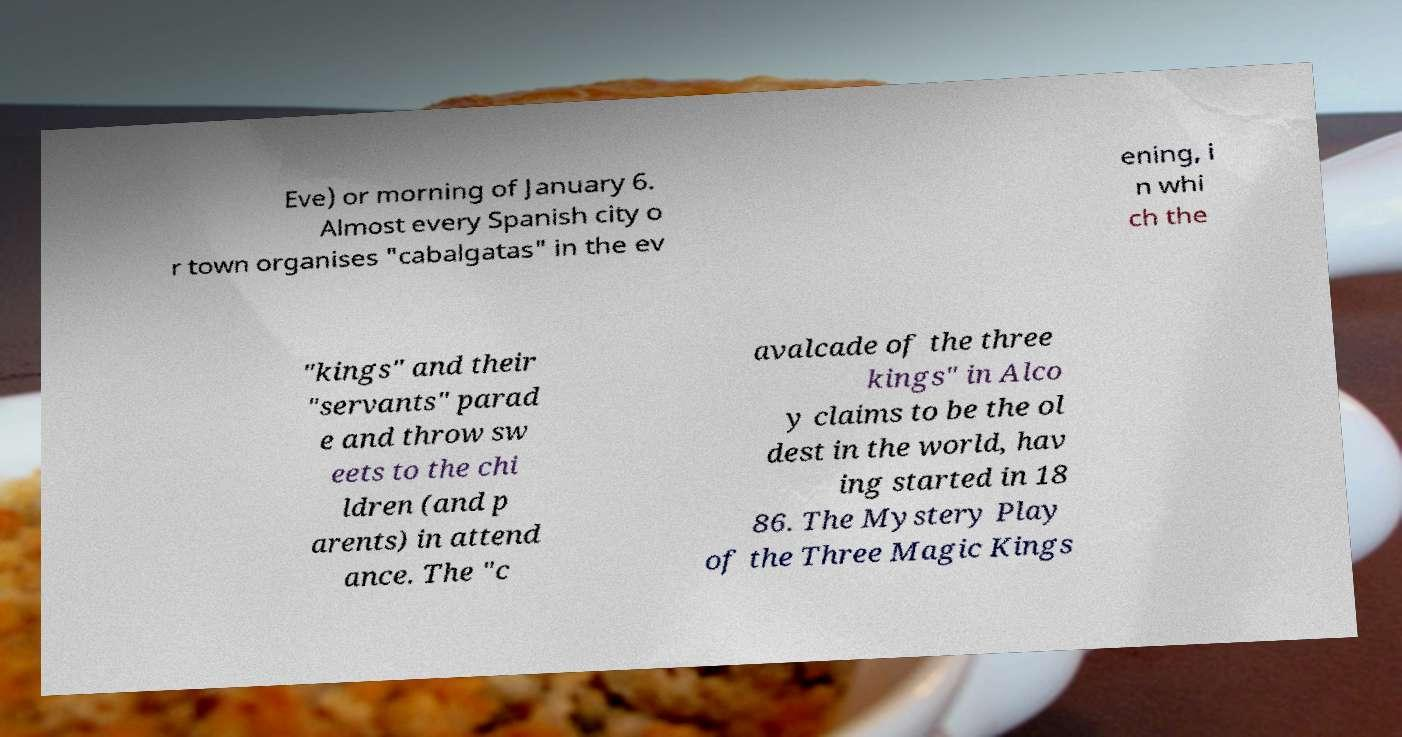For documentation purposes, I need the text within this image transcribed. Could you provide that? Eve) or morning of January 6. Almost every Spanish city o r town organises "cabalgatas" in the ev ening, i n whi ch the "kings" and their "servants" parad e and throw sw eets to the chi ldren (and p arents) in attend ance. The "c avalcade of the three kings" in Alco y claims to be the ol dest in the world, hav ing started in 18 86. The Mystery Play of the Three Magic Kings 